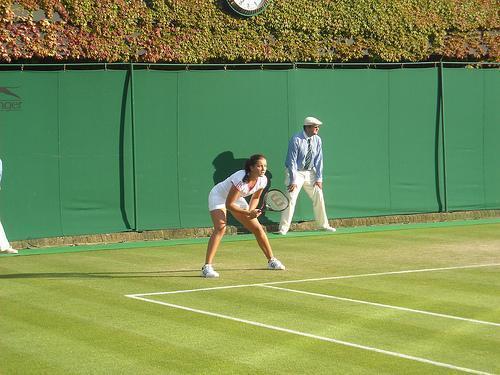How many tennis players are visible in the photo?
Give a very brief answer. 1. How many clocks are in the photo?
Give a very brief answer. 1. How many people are visible in the photo?
Give a very brief answer. 3. 